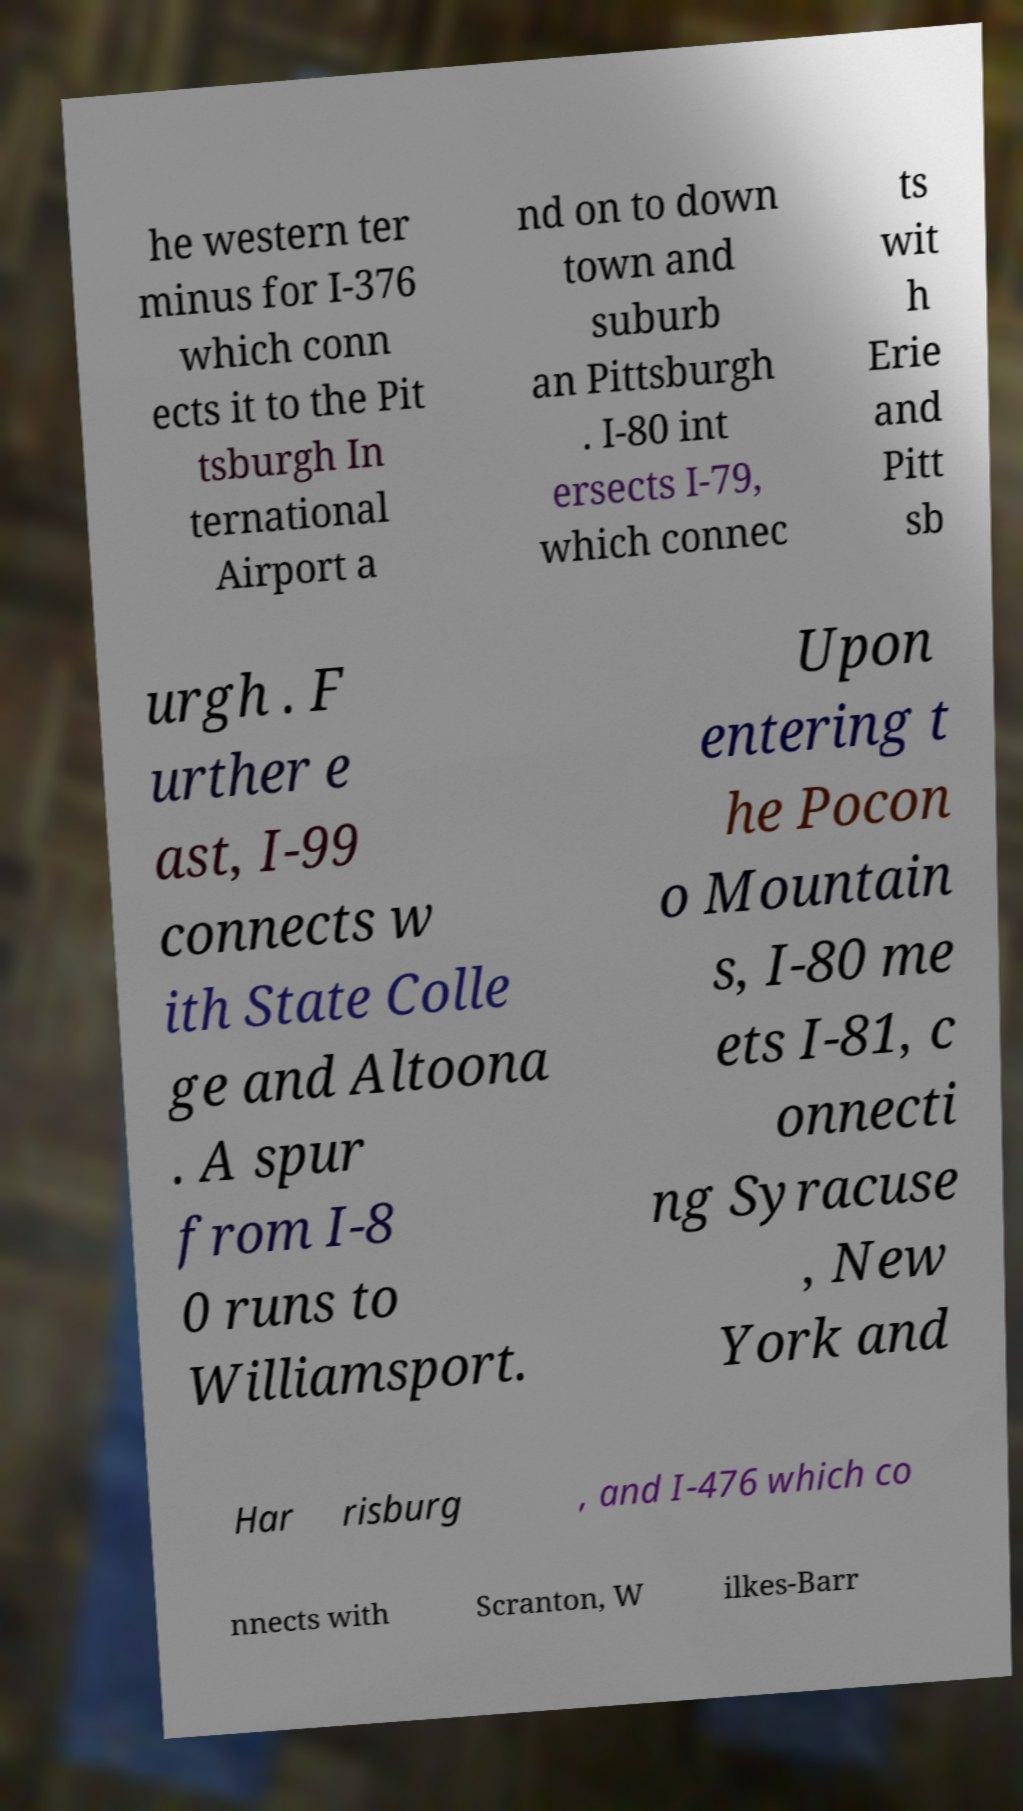For documentation purposes, I need the text within this image transcribed. Could you provide that? he western ter minus for I-376 which conn ects it to the Pit tsburgh In ternational Airport a nd on to down town and suburb an Pittsburgh . I-80 int ersects I-79, which connec ts wit h Erie and Pitt sb urgh . F urther e ast, I-99 connects w ith State Colle ge and Altoona . A spur from I-8 0 runs to Williamsport. Upon entering t he Pocon o Mountain s, I-80 me ets I-81, c onnecti ng Syracuse , New York and Har risburg , and I-476 which co nnects with Scranton, W ilkes-Barr 